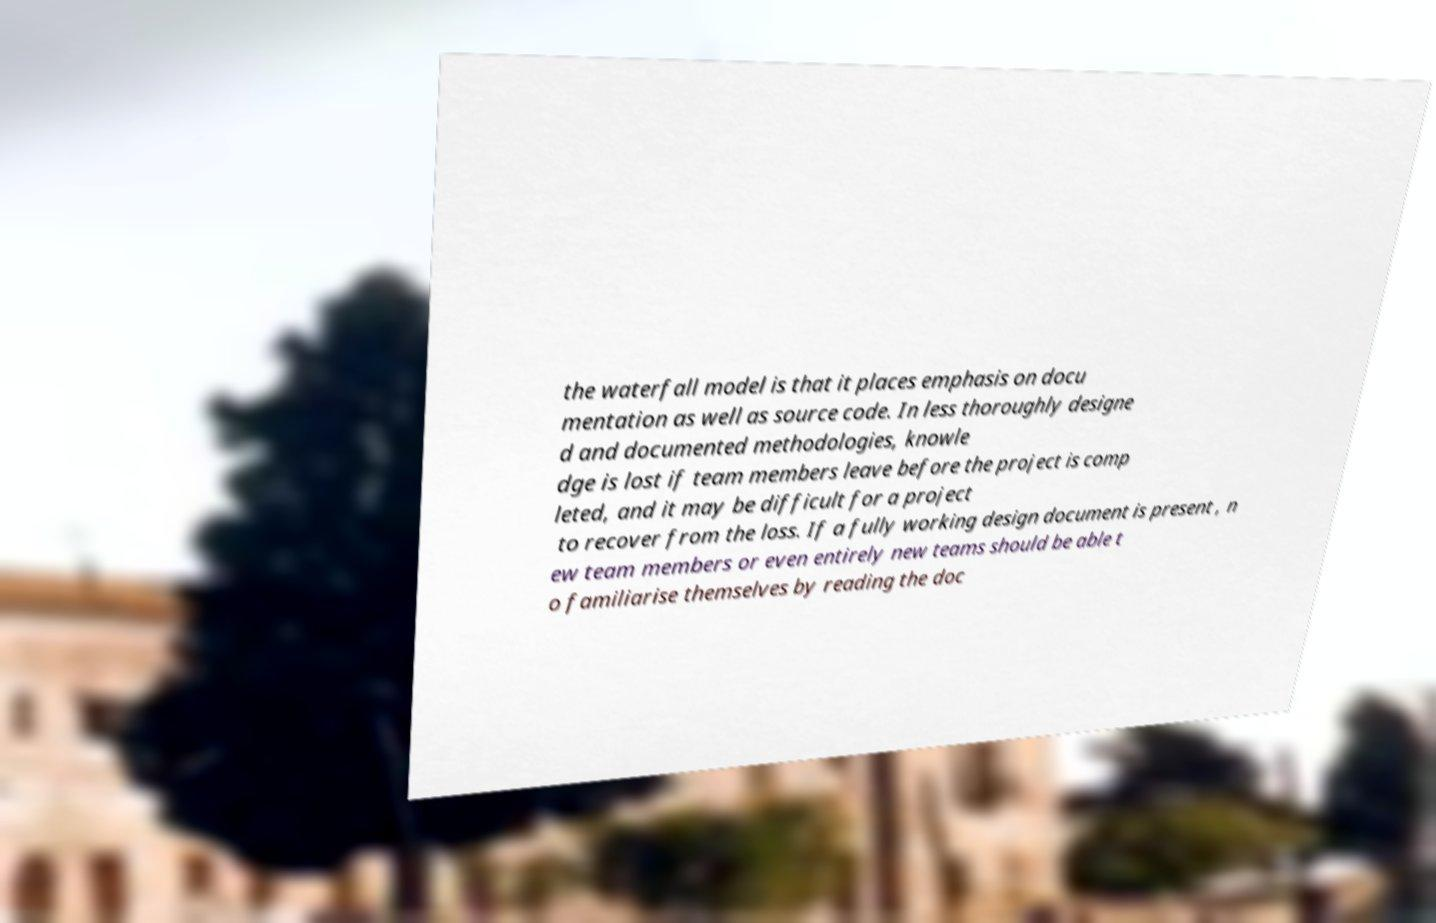Could you assist in decoding the text presented in this image and type it out clearly? the waterfall model is that it places emphasis on docu mentation as well as source code. In less thoroughly designe d and documented methodologies, knowle dge is lost if team members leave before the project is comp leted, and it may be difficult for a project to recover from the loss. If a fully working design document is present , n ew team members or even entirely new teams should be able t o familiarise themselves by reading the doc 